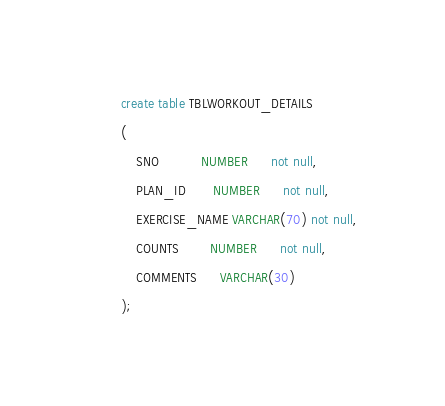<code> <loc_0><loc_0><loc_500><loc_500><_SQL_>create table TBLWORKOUT_DETAILS
(
    SNO           NUMBER      not null,
    PLAN_ID       NUMBER      not null,
    EXERCISE_NAME VARCHAR(70) not null,
    COUNTS        NUMBER      not null,
    COMMENTS      VARCHAR(30)
);


</code> 